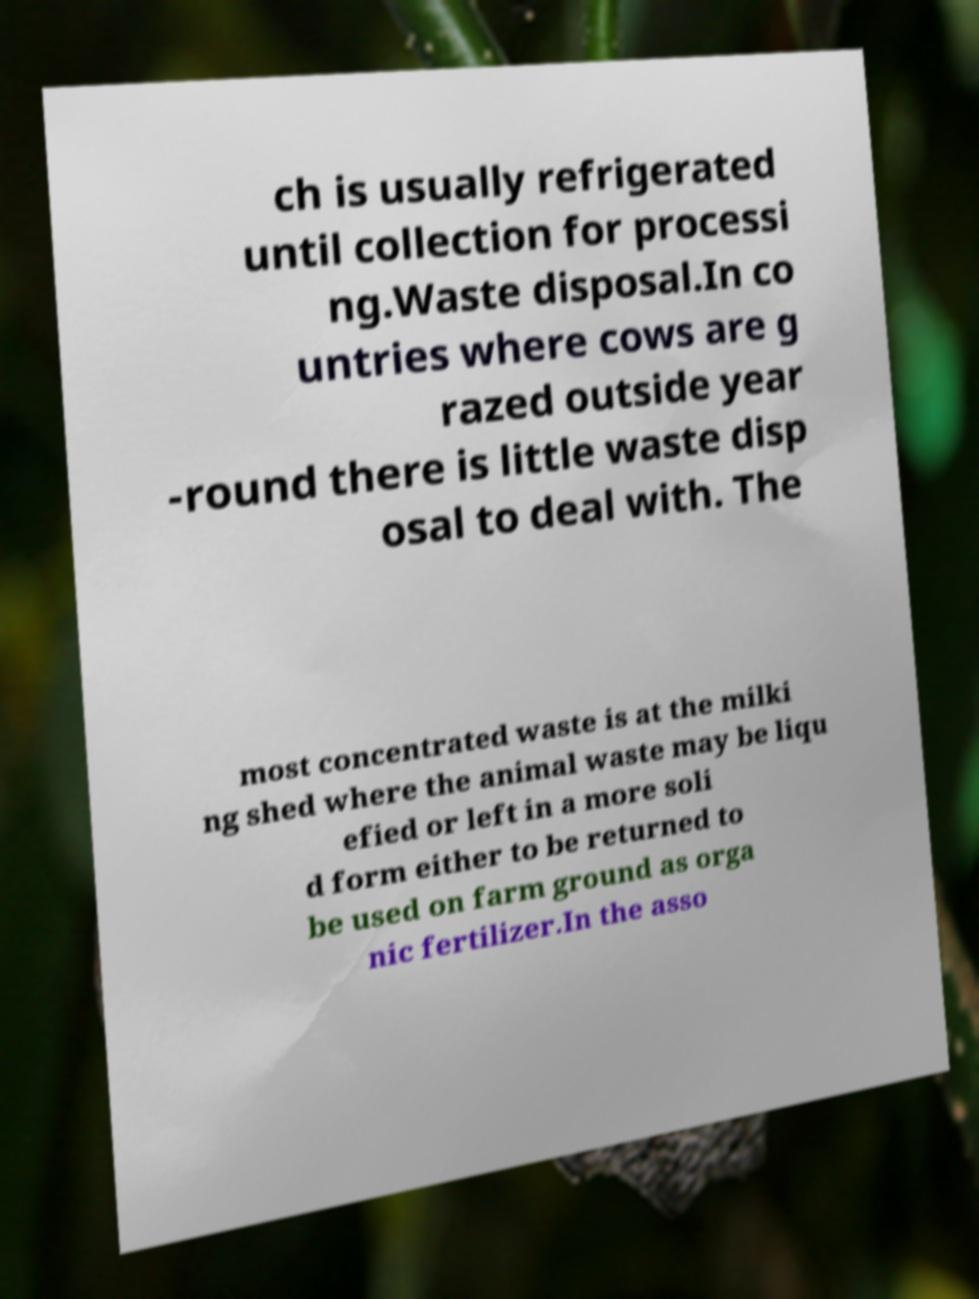There's text embedded in this image that I need extracted. Can you transcribe it verbatim? ch is usually refrigerated until collection for processi ng.Waste disposal.In co untries where cows are g razed outside year -round there is little waste disp osal to deal with. The most concentrated waste is at the milki ng shed where the animal waste may be liqu efied or left in a more soli d form either to be returned to be used on farm ground as orga nic fertilizer.In the asso 